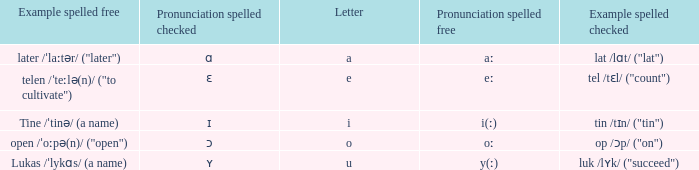Write the full table. {'header': ['Example spelled free', 'Pronunciation spelled checked', 'Letter', 'Pronunciation spelled free', 'Example spelled checked'], 'rows': [['later /ˈlaːtər/ ("later")', 'ɑ', 'a', 'aː', 'lat /lɑt/ ("lat")'], ['telen /ˈteːlə(n)/ ("to cultivate")', 'ɛ', 'e', 'eː', 'tel /tɛl/ ("count")'], ['Tine /ˈtinə/ (a name)', 'ɪ', 'i', 'i(ː)', 'tin /tɪn/ ("tin")'], ['open /ˈoːpə(n)/ ("open")', 'ɔ', 'o', 'oː', 'op /ɔp/ ("on")'], ['Lukas /ˈlykɑs/ (a name)', 'ʏ', 'u', 'y(ː)', 'luk /lʏk/ ("succeed")']]} What is Pronunciation Spelled Checked, when Example Spelled Checked is "tin /tɪn/ ("tin")" Ɪ. 